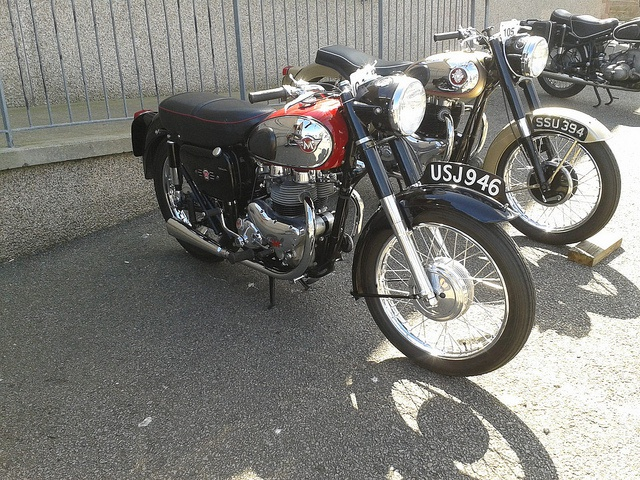Describe the objects in this image and their specific colors. I can see motorcycle in darkgray, black, gray, and white tones, motorcycle in darkgray, gray, white, and black tones, and motorcycle in darkgray, gray, black, and lightgray tones in this image. 